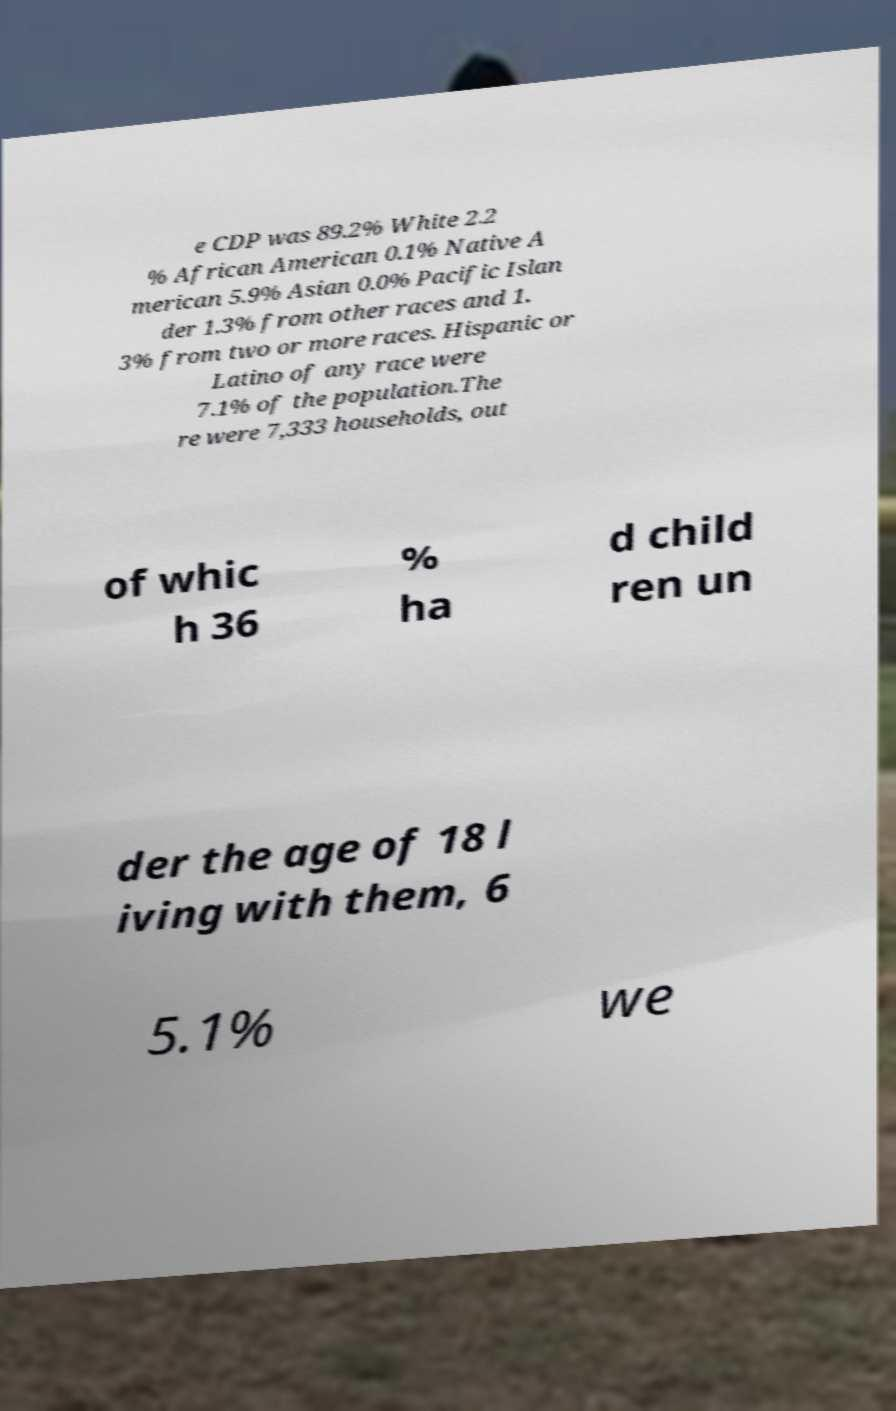Can you read and provide the text displayed in the image?This photo seems to have some interesting text. Can you extract and type it out for me? e CDP was 89.2% White 2.2 % African American 0.1% Native A merican 5.9% Asian 0.0% Pacific Islan der 1.3% from other races and 1. 3% from two or more races. Hispanic or Latino of any race were 7.1% of the population.The re were 7,333 households, out of whic h 36 % ha d child ren un der the age of 18 l iving with them, 6 5.1% we 